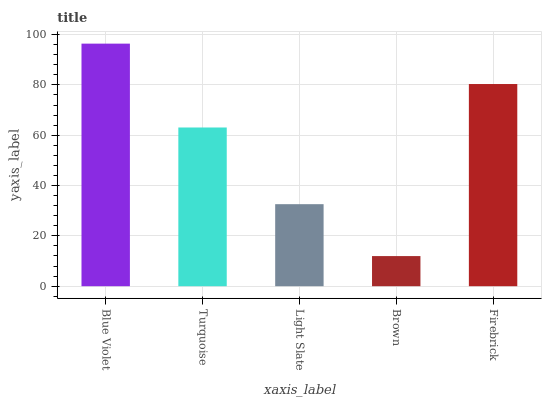Is Turquoise the minimum?
Answer yes or no. No. Is Turquoise the maximum?
Answer yes or no. No. Is Blue Violet greater than Turquoise?
Answer yes or no. Yes. Is Turquoise less than Blue Violet?
Answer yes or no. Yes. Is Turquoise greater than Blue Violet?
Answer yes or no. No. Is Blue Violet less than Turquoise?
Answer yes or no. No. Is Turquoise the high median?
Answer yes or no. Yes. Is Turquoise the low median?
Answer yes or no. Yes. Is Brown the high median?
Answer yes or no. No. Is Blue Violet the low median?
Answer yes or no. No. 